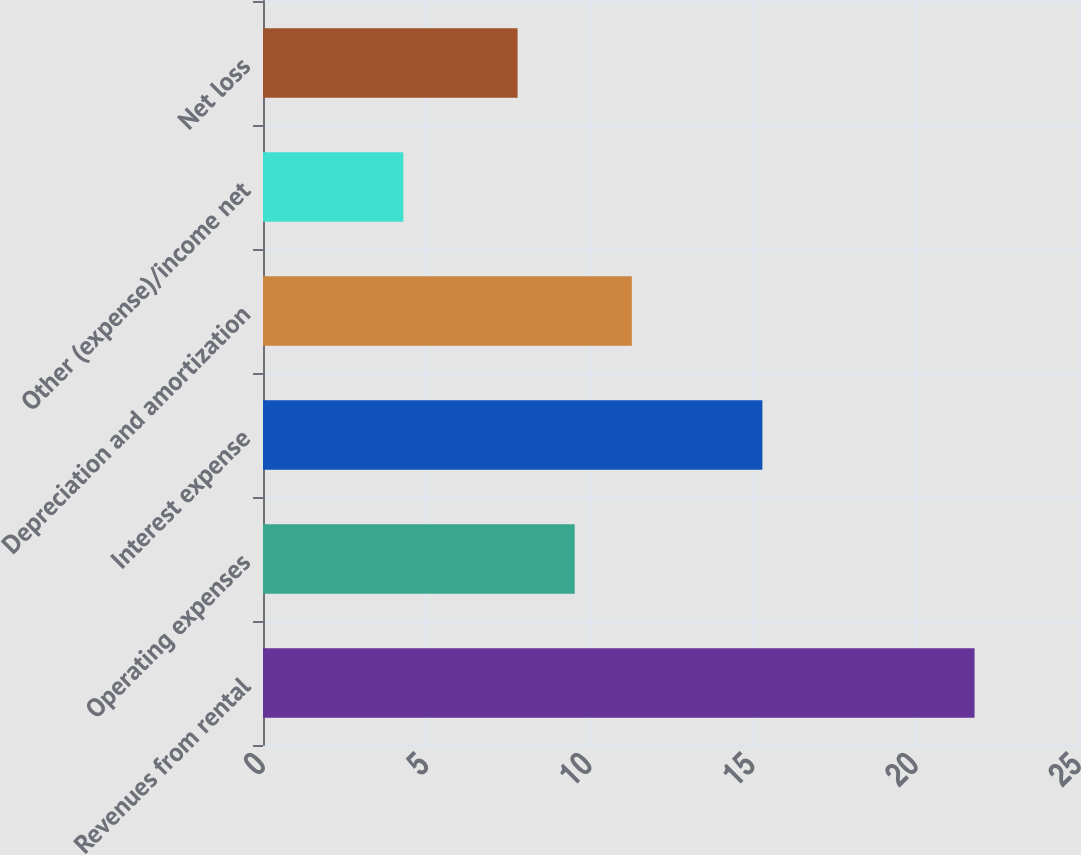Convert chart to OTSL. <chart><loc_0><loc_0><loc_500><loc_500><bar_chart><fcel>Revenues from rental<fcel>Operating expenses<fcel>Interest expense<fcel>Depreciation and amortization<fcel>Other (expense)/income net<fcel>Net loss<nl><fcel>21.8<fcel>9.55<fcel>15.3<fcel>11.3<fcel>4.3<fcel>7.8<nl></chart> 